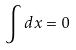Convert formula to latex. <formula><loc_0><loc_0><loc_500><loc_500>\int d x = 0</formula> 